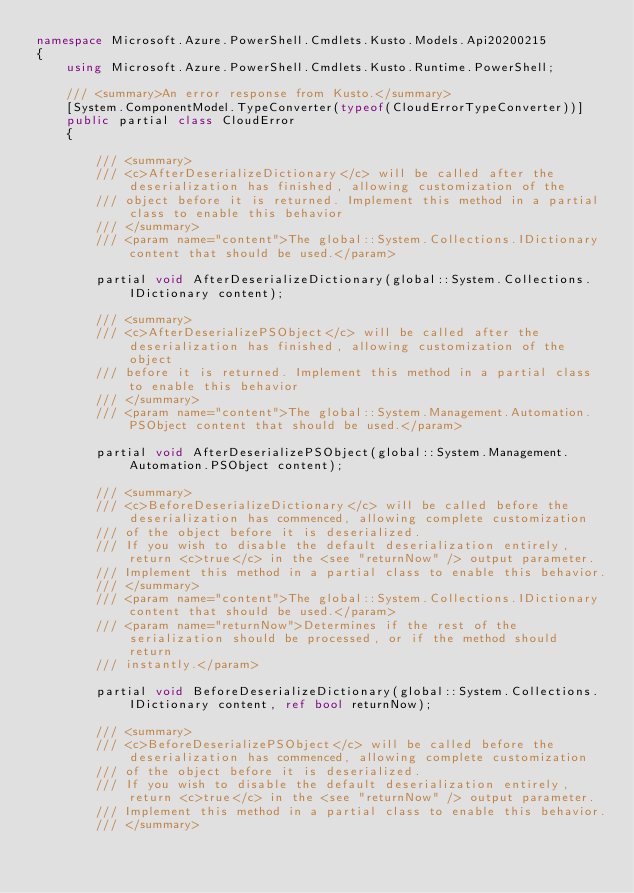<code> <loc_0><loc_0><loc_500><loc_500><_C#_>namespace Microsoft.Azure.PowerShell.Cmdlets.Kusto.Models.Api20200215
{
    using Microsoft.Azure.PowerShell.Cmdlets.Kusto.Runtime.PowerShell;

    /// <summary>An error response from Kusto.</summary>
    [System.ComponentModel.TypeConverter(typeof(CloudErrorTypeConverter))]
    public partial class CloudError
    {

        /// <summary>
        /// <c>AfterDeserializeDictionary</c> will be called after the deserialization has finished, allowing customization of the
        /// object before it is returned. Implement this method in a partial class to enable this behavior
        /// </summary>
        /// <param name="content">The global::System.Collections.IDictionary content that should be used.</param>

        partial void AfterDeserializeDictionary(global::System.Collections.IDictionary content);

        /// <summary>
        /// <c>AfterDeserializePSObject</c> will be called after the deserialization has finished, allowing customization of the object
        /// before it is returned. Implement this method in a partial class to enable this behavior
        /// </summary>
        /// <param name="content">The global::System.Management.Automation.PSObject content that should be used.</param>

        partial void AfterDeserializePSObject(global::System.Management.Automation.PSObject content);

        /// <summary>
        /// <c>BeforeDeserializeDictionary</c> will be called before the deserialization has commenced, allowing complete customization
        /// of the object before it is deserialized.
        /// If you wish to disable the default deserialization entirely, return <c>true</c> in the <see "returnNow" /> output parameter.
        /// Implement this method in a partial class to enable this behavior.
        /// </summary>
        /// <param name="content">The global::System.Collections.IDictionary content that should be used.</param>
        /// <param name="returnNow">Determines if the rest of the serialization should be processed, or if the method should return
        /// instantly.</param>

        partial void BeforeDeserializeDictionary(global::System.Collections.IDictionary content, ref bool returnNow);

        /// <summary>
        /// <c>BeforeDeserializePSObject</c> will be called before the deserialization has commenced, allowing complete customization
        /// of the object before it is deserialized.
        /// If you wish to disable the default deserialization entirely, return <c>true</c> in the <see "returnNow" /> output parameter.
        /// Implement this method in a partial class to enable this behavior.
        /// </summary></code> 